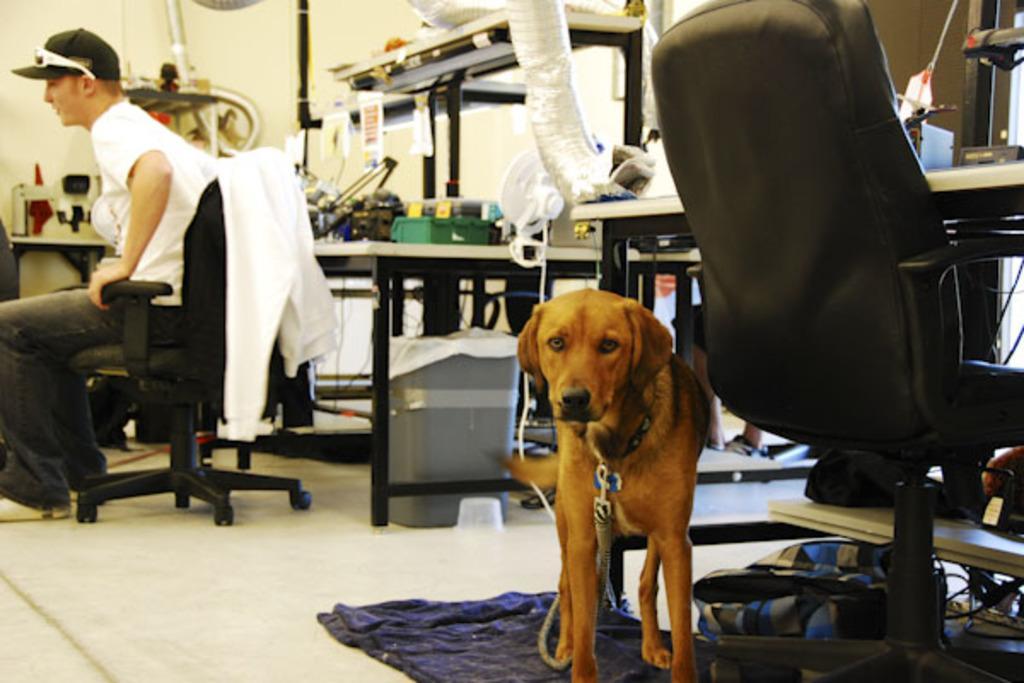In one or two sentences, can you explain what this image depicts? This picture shows a dog which is standing behind the chair on the cloth. In the background there is a man sitting in the chair and there is table on which some equipment is placed. There is a wall here. 